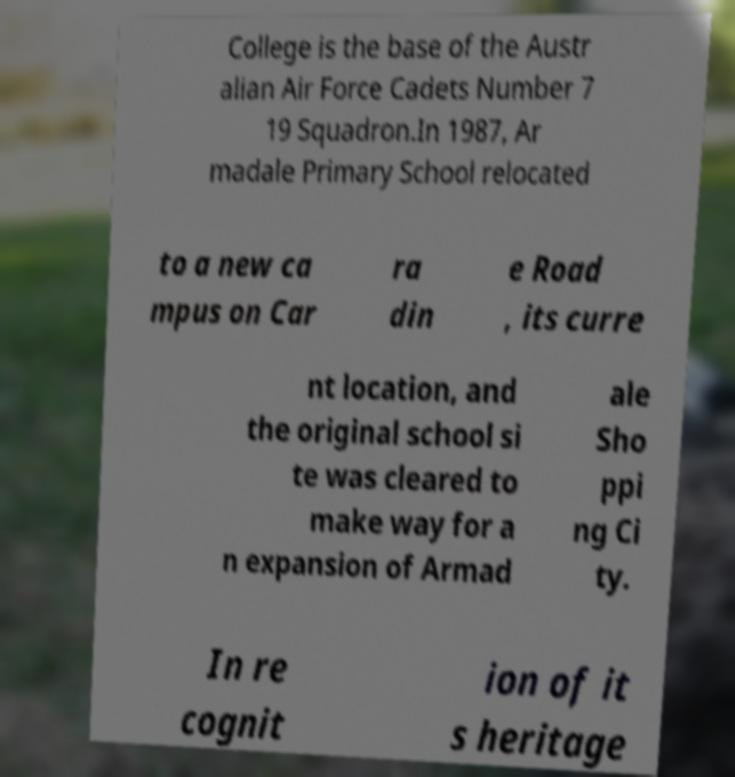Can you read and provide the text displayed in the image?This photo seems to have some interesting text. Can you extract and type it out for me? College is the base of the Austr alian Air Force Cadets Number 7 19 Squadron.In 1987, Ar madale Primary School relocated to a new ca mpus on Car ra din e Road , its curre nt location, and the original school si te was cleared to make way for a n expansion of Armad ale Sho ppi ng Ci ty. In re cognit ion of it s heritage 